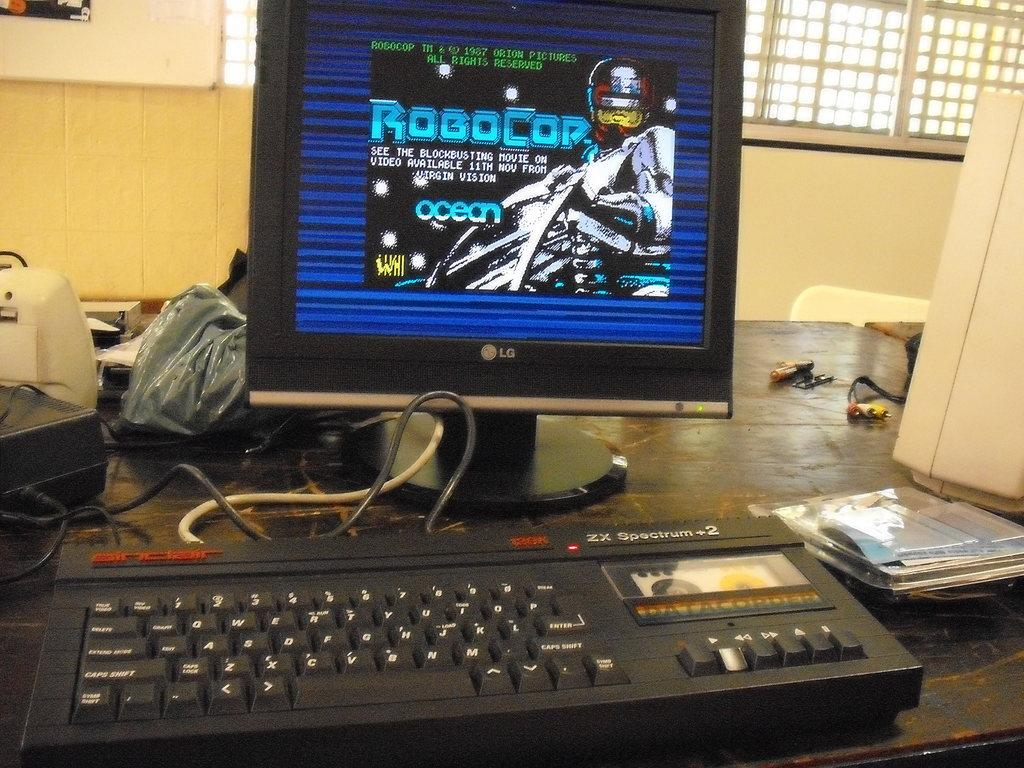<image>
Share a concise interpretation of the image provided. A computer monitor showing Robocop with dark blue and black background. 